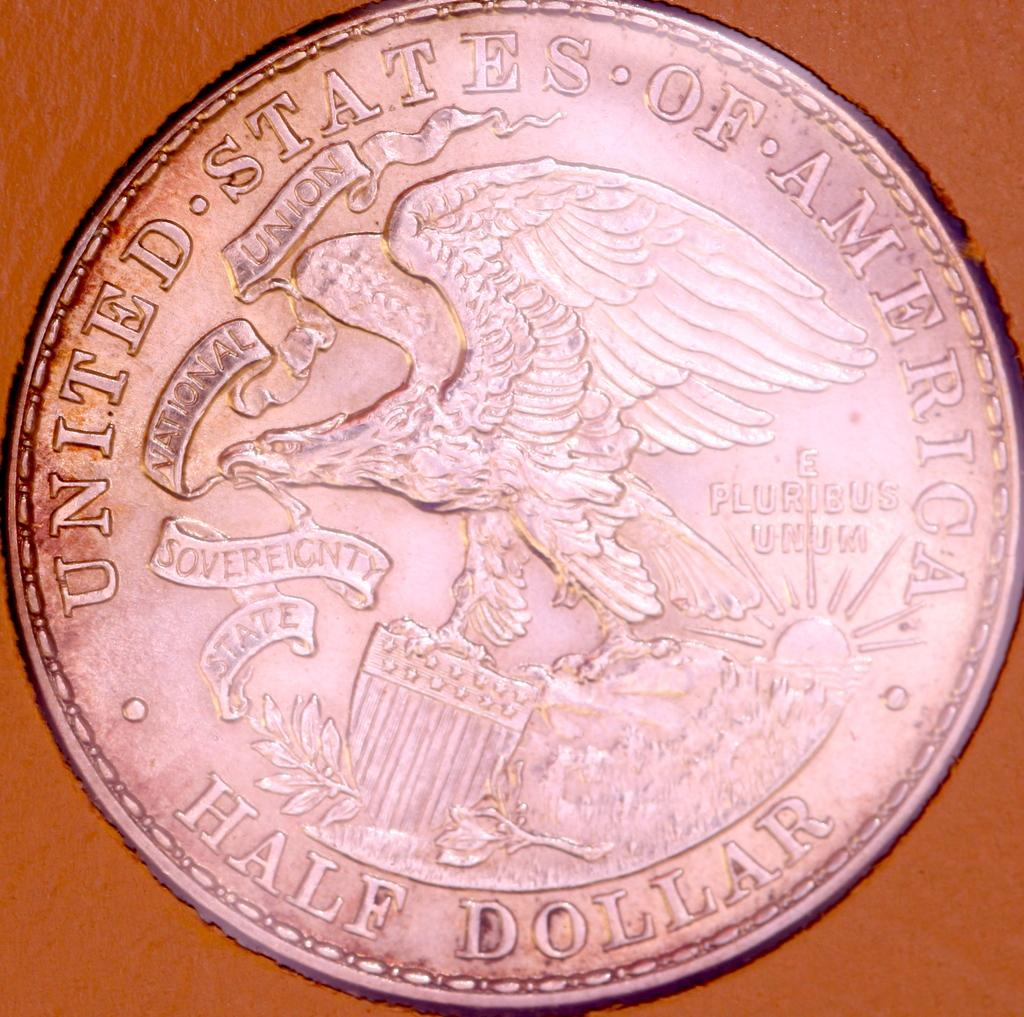<image>
Present a compact description of the photo's key features. An old silver Unites States of America half dollar. 